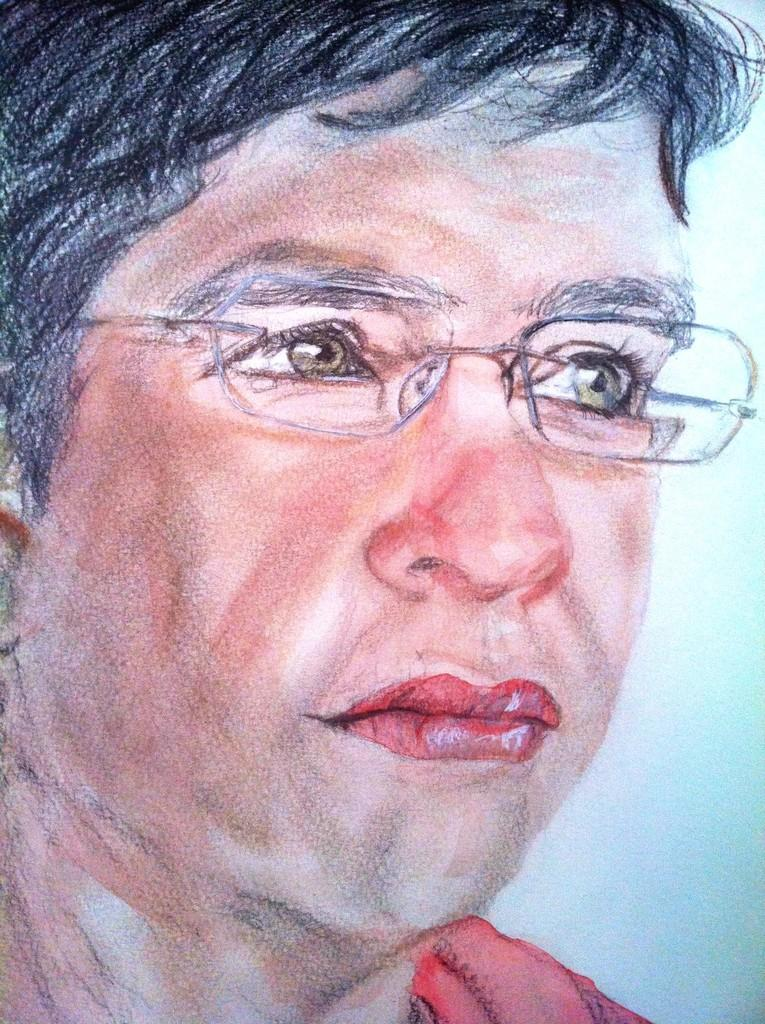What type of image is shown in the picture? The image is a drawing. What is the main subject of the drawing? The drawing depicts a person. What accessory is the person wearing in the drawing? The person is wearing spectacles. Is the person in the drawing stuck in quicksand? There is no quicksand present in the drawing, and the person is not depicted as being stuck in any substance. 